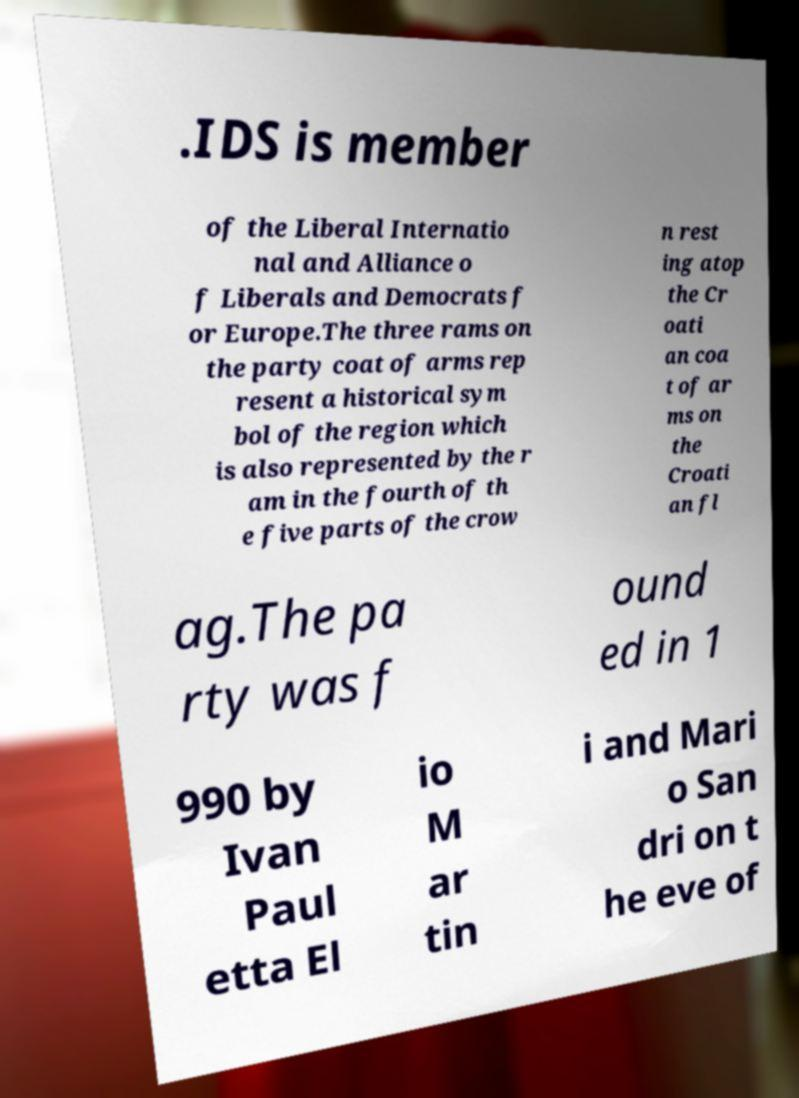I need the written content from this picture converted into text. Can you do that? .IDS is member of the Liberal Internatio nal and Alliance o f Liberals and Democrats f or Europe.The three rams on the party coat of arms rep resent a historical sym bol of the region which is also represented by the r am in the fourth of th e five parts of the crow n rest ing atop the Cr oati an coa t of ar ms on the Croati an fl ag.The pa rty was f ound ed in 1 990 by Ivan Paul etta El io M ar tin i and Mari o San dri on t he eve of 